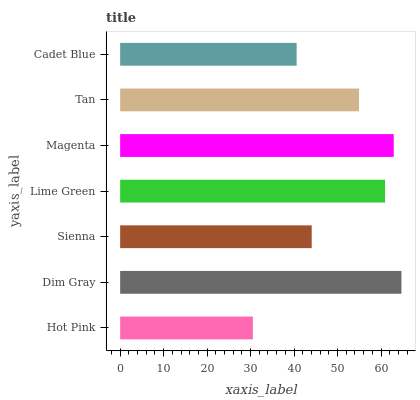Is Hot Pink the minimum?
Answer yes or no. Yes. Is Dim Gray the maximum?
Answer yes or no. Yes. Is Sienna the minimum?
Answer yes or no. No. Is Sienna the maximum?
Answer yes or no. No. Is Dim Gray greater than Sienna?
Answer yes or no. Yes. Is Sienna less than Dim Gray?
Answer yes or no. Yes. Is Sienna greater than Dim Gray?
Answer yes or no. No. Is Dim Gray less than Sienna?
Answer yes or no. No. Is Tan the high median?
Answer yes or no. Yes. Is Tan the low median?
Answer yes or no. Yes. Is Dim Gray the high median?
Answer yes or no. No. Is Cadet Blue the low median?
Answer yes or no. No. 